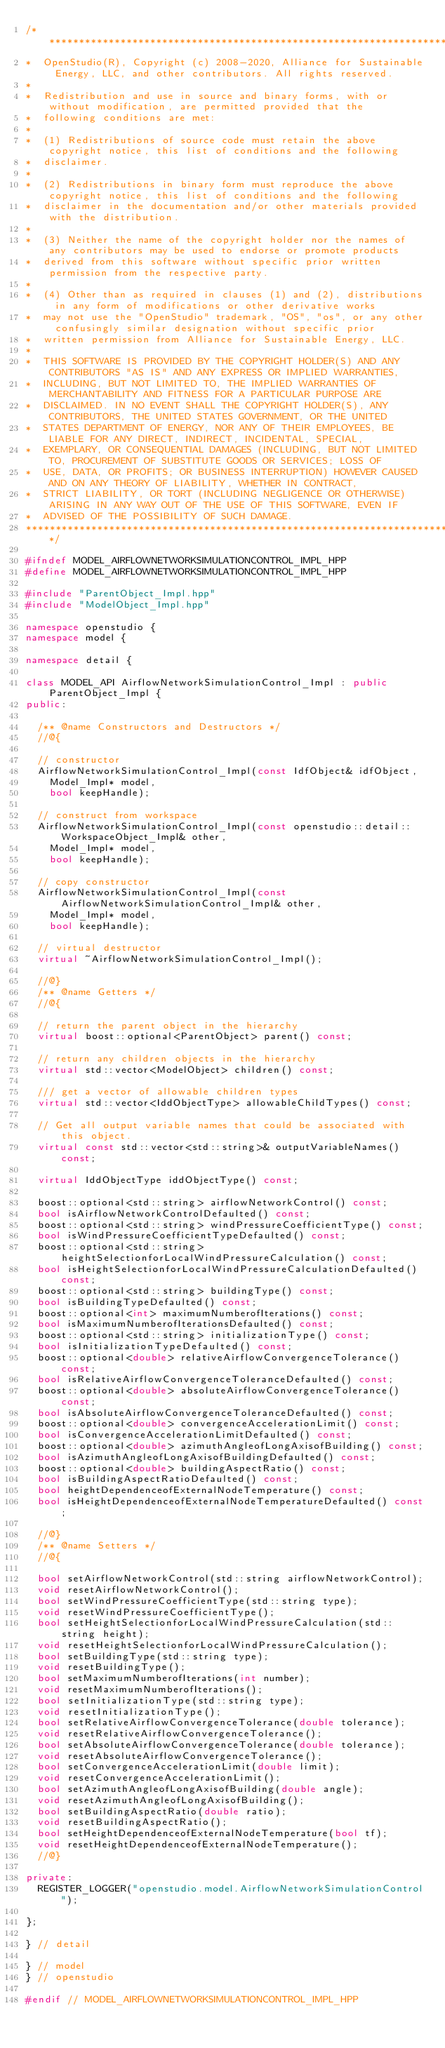Convert code to text. <code><loc_0><loc_0><loc_500><loc_500><_C++_>/***********************************************************************************************************************
*  OpenStudio(R), Copyright (c) 2008-2020, Alliance for Sustainable Energy, LLC, and other contributors. All rights reserved.
*
*  Redistribution and use in source and binary forms, with or without modification, are permitted provided that the
*  following conditions are met:
*
*  (1) Redistributions of source code must retain the above copyright notice, this list of conditions and the following
*  disclaimer.
*
*  (2) Redistributions in binary form must reproduce the above copyright notice, this list of conditions and the following
*  disclaimer in the documentation and/or other materials provided with the distribution.
*
*  (3) Neither the name of the copyright holder nor the names of any contributors may be used to endorse or promote products
*  derived from this software without specific prior written permission from the respective party.
*
*  (4) Other than as required in clauses (1) and (2), distributions in any form of modifications or other derivative works
*  may not use the "OpenStudio" trademark, "OS", "os", or any other confusingly similar designation without specific prior
*  written permission from Alliance for Sustainable Energy, LLC.
*
*  THIS SOFTWARE IS PROVIDED BY THE COPYRIGHT HOLDER(S) AND ANY CONTRIBUTORS "AS IS" AND ANY EXPRESS OR IMPLIED WARRANTIES,
*  INCLUDING, BUT NOT LIMITED TO, THE IMPLIED WARRANTIES OF MERCHANTABILITY AND FITNESS FOR A PARTICULAR PURPOSE ARE
*  DISCLAIMED. IN NO EVENT SHALL THE COPYRIGHT HOLDER(S), ANY CONTRIBUTORS, THE UNITED STATES GOVERNMENT, OR THE UNITED
*  STATES DEPARTMENT OF ENERGY, NOR ANY OF THEIR EMPLOYEES, BE LIABLE FOR ANY DIRECT, INDIRECT, INCIDENTAL, SPECIAL,
*  EXEMPLARY, OR CONSEQUENTIAL DAMAGES (INCLUDING, BUT NOT LIMITED TO, PROCUREMENT OF SUBSTITUTE GOODS OR SERVICES; LOSS OF
*  USE, DATA, OR PROFITS; OR BUSINESS INTERRUPTION) HOWEVER CAUSED AND ON ANY THEORY OF LIABILITY, WHETHER IN CONTRACT,
*  STRICT LIABILITY, OR TORT (INCLUDING NEGLIGENCE OR OTHERWISE) ARISING IN ANY WAY OUT OF THE USE OF THIS SOFTWARE, EVEN IF
*  ADVISED OF THE POSSIBILITY OF SUCH DAMAGE.
***********************************************************************************************************************/

#ifndef MODEL_AIRFLOWNETWORKSIMULATIONCONTROL_IMPL_HPP
#define MODEL_AIRFLOWNETWORKSIMULATIONCONTROL_IMPL_HPP

#include "ParentObject_Impl.hpp"
#include "ModelObject_Impl.hpp"

namespace openstudio {
namespace model {

namespace detail {

class MODEL_API AirflowNetworkSimulationControl_Impl : public ParentObject_Impl {
public:

  /** @name Constructors and Destructors */
  //@{

  // constructor
  AirflowNetworkSimulationControl_Impl(const IdfObject& idfObject,
    Model_Impl* model,
    bool keepHandle);

  // construct from workspace
  AirflowNetworkSimulationControl_Impl(const openstudio::detail::WorkspaceObject_Impl& other,
    Model_Impl* model,
    bool keepHandle);

  // copy constructor
  AirflowNetworkSimulationControl_Impl(const AirflowNetworkSimulationControl_Impl& other,
    Model_Impl* model,
    bool keepHandle);

  // virtual destructor
  virtual ~AirflowNetworkSimulationControl_Impl();

  //@}
  /** @name Getters */
  //@{

  // return the parent object in the hierarchy
  virtual boost::optional<ParentObject> parent() const;

  // return any children objects in the hierarchy
  virtual std::vector<ModelObject> children() const;

  /// get a vector of allowable children types
  virtual std::vector<IddObjectType> allowableChildTypes() const;

  // Get all output variable names that could be associated with this object.
  virtual const std::vector<std::string>& outputVariableNames() const;

  virtual IddObjectType iddObjectType() const;

  boost::optional<std::string> airflowNetworkControl() const;
  bool isAirflowNetworkControlDefaulted() const;
  boost::optional<std::string> windPressureCoefficientType() const;
  bool isWindPressureCoefficientTypeDefaulted() const;
  boost::optional<std::string> heightSelectionforLocalWindPressureCalculation() const;
  bool isHeightSelectionforLocalWindPressureCalculationDefaulted() const;
  boost::optional<std::string> buildingType() const;
  bool isBuildingTypeDefaulted() const;
  boost::optional<int> maximumNumberofIterations() const;
  bool isMaximumNumberofIterationsDefaulted() const;
  boost::optional<std::string> initializationType() const;
  bool isInitializationTypeDefaulted() const;
  boost::optional<double> relativeAirflowConvergenceTolerance() const;
  bool isRelativeAirflowConvergenceToleranceDefaulted() const;
  boost::optional<double> absoluteAirflowConvergenceTolerance() const;
  bool isAbsoluteAirflowConvergenceToleranceDefaulted() const;
  boost::optional<double> convergenceAccelerationLimit() const;
  bool isConvergenceAccelerationLimitDefaulted() const;
  boost::optional<double> azimuthAngleofLongAxisofBuilding() const;
  bool isAzimuthAngleofLongAxisofBuildingDefaulted() const;
  boost::optional<double> buildingAspectRatio() const;
  bool isBuildingAspectRatioDefaulted() const;
  bool heightDependenceofExternalNodeTemperature() const;
  bool isHeightDependenceofExternalNodeTemperatureDefaulted() const;

  //@}
  /** @name Setters */
  //@{

  bool setAirflowNetworkControl(std::string airflowNetworkControl);
  void resetAirflowNetworkControl();
  bool setWindPressureCoefficientType(std::string type);
  void resetWindPressureCoefficientType();
  bool setHeightSelectionforLocalWindPressureCalculation(std::string height);
  void resetHeightSelectionforLocalWindPressureCalculation();
  bool setBuildingType(std::string type);
  void resetBuildingType();
  bool setMaximumNumberofIterations(int number);
  void resetMaximumNumberofIterations();
  bool setInitializationType(std::string type);
  void resetInitializationType();
  bool setRelativeAirflowConvergenceTolerance(double tolerance);
  void resetRelativeAirflowConvergenceTolerance();
  bool setAbsoluteAirflowConvergenceTolerance(double tolerance);
  void resetAbsoluteAirflowConvergenceTolerance();
  bool setConvergenceAccelerationLimit(double limit);
  void resetConvergenceAccelerationLimit();
  bool setAzimuthAngleofLongAxisofBuilding(double angle);
  void resetAzimuthAngleofLongAxisofBuilding();
  bool setBuildingAspectRatio(double ratio);
  void resetBuildingAspectRatio();
  bool setHeightDependenceofExternalNodeTemperature(bool tf);
  void resetHeightDependenceofExternalNodeTemperature();
  //@}

private:
  REGISTER_LOGGER("openstudio.model.AirflowNetworkSimulationControl");

};

} // detail

} // model
} // openstudio

#endif // MODEL_AIRFLOWNETWORKSIMULATIONCONTROL_IMPL_HPP
</code> 